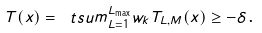Convert formula to latex. <formula><loc_0><loc_0><loc_500><loc_500>T ( x ) = \ t s u m _ { L = 1 } ^ { L _ { \max } } w _ { k } T _ { L , M } ( x ) \geq - \delta \text {.}</formula> 